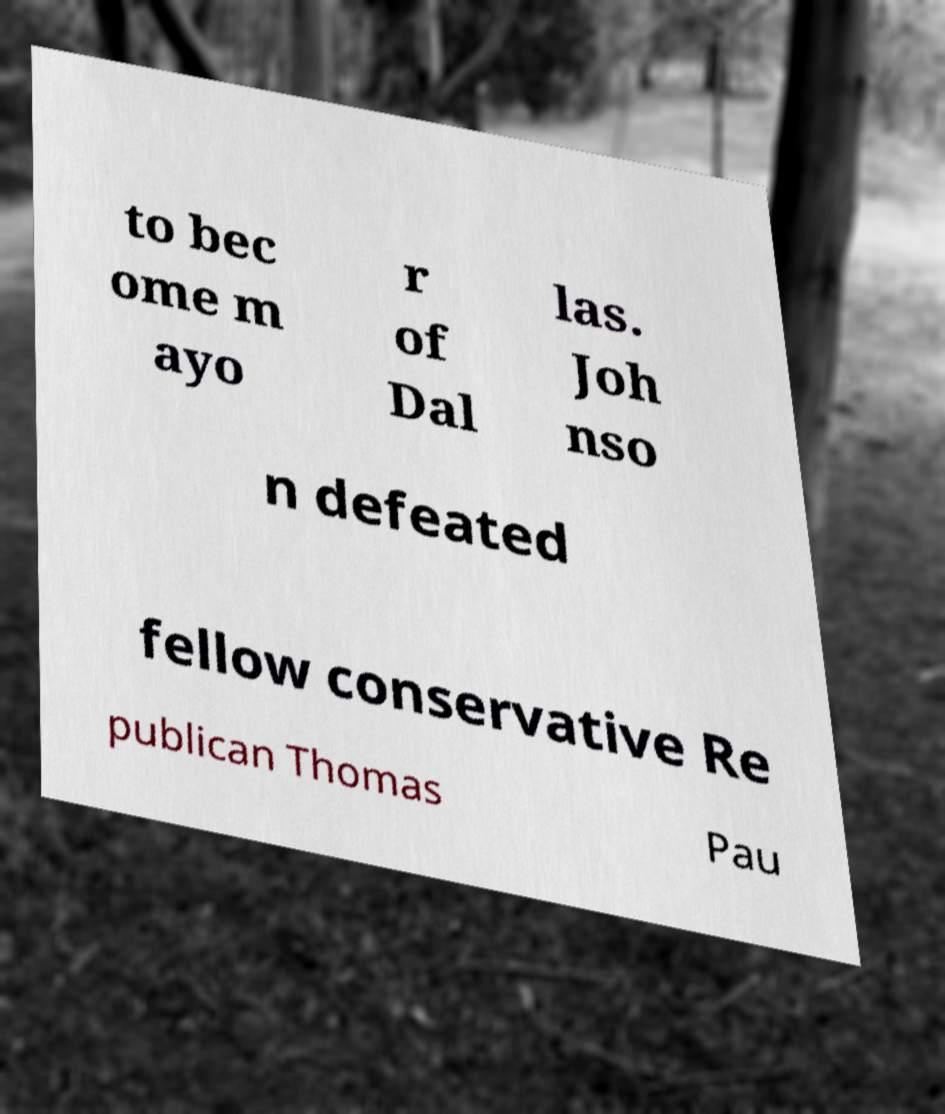There's text embedded in this image that I need extracted. Can you transcribe it verbatim? to bec ome m ayo r of Dal las. Joh nso n defeated fellow conservative Re publican Thomas Pau 